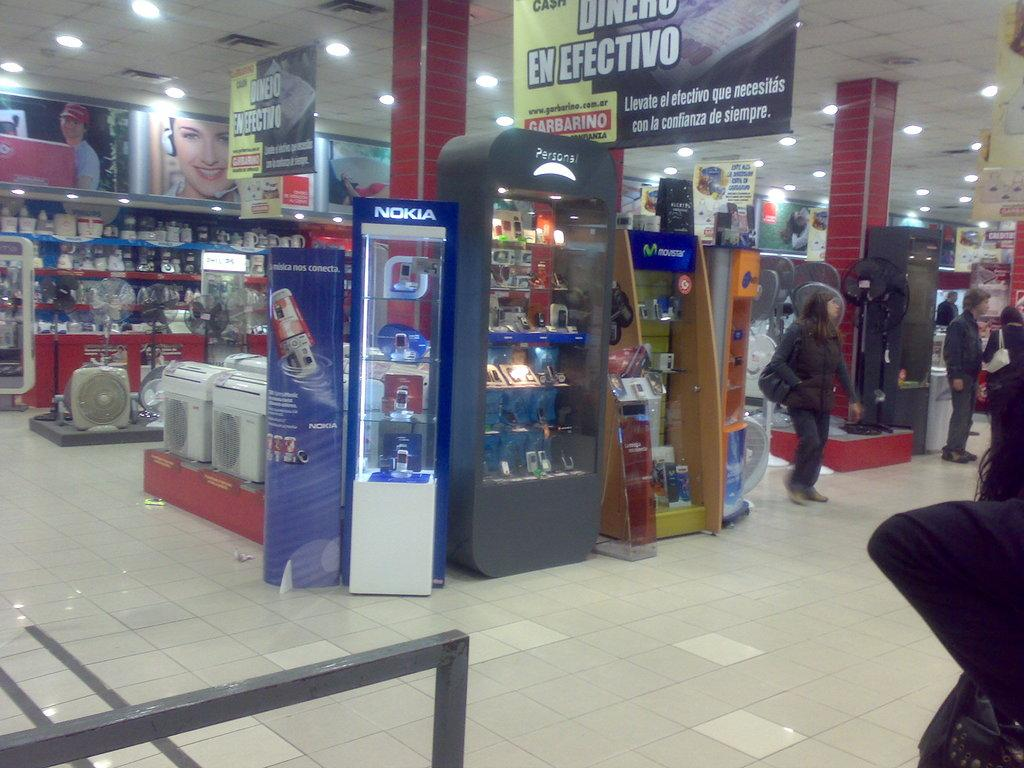Provide a one-sentence caption for the provided image. A store with many aisles, displays and customers, Nokia being the name on the most prominent display. 